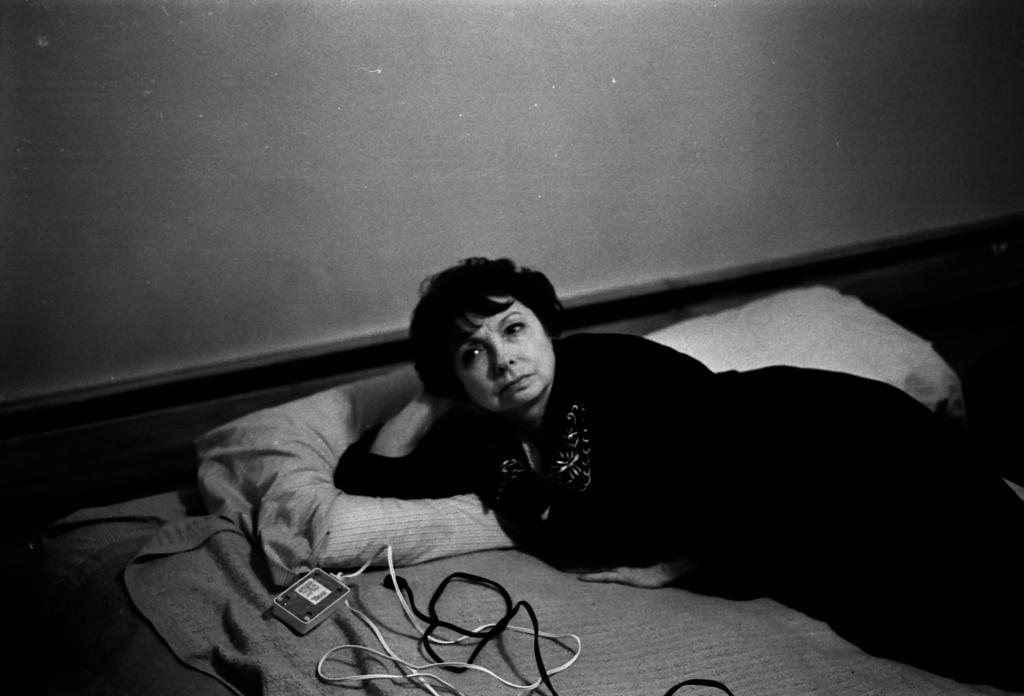What is the color scheme of the image? The image is black and white. What is the woman in the image doing? The woman is lying on the bed in the image. What objects are on the bed with the woman? Cables, pillows, and a board are on the bed. What can be seen in the background of the image? There is a wall visible in the background of the image. What type of laborer can be seen working in the image? There is no laborer present in the image; it features a woman lying on a bed with various objects. Can you see any smoke coming from the wall in the image? There is no smoke visible in the image; it is a black and white image of a woman lying on a bed with objects. 